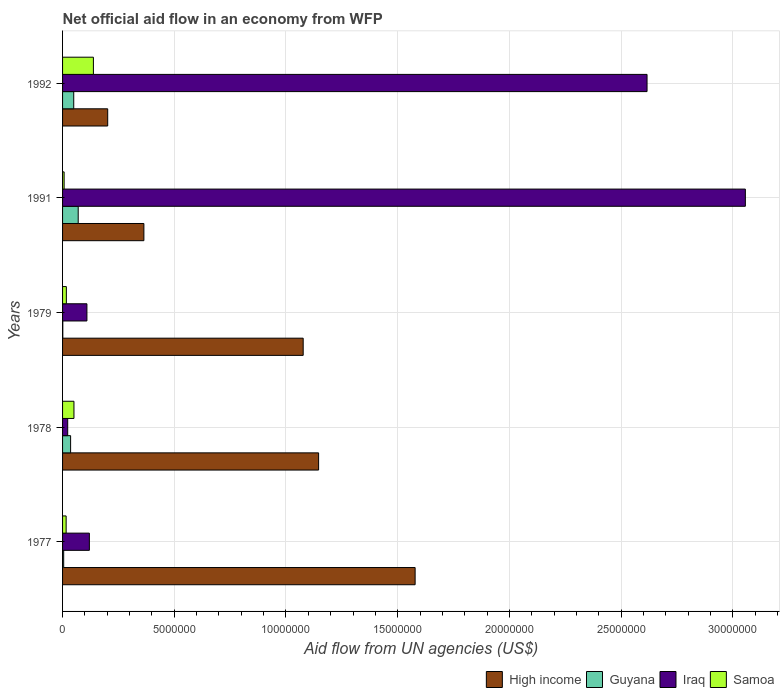How many different coloured bars are there?
Make the answer very short. 4. How many groups of bars are there?
Offer a very short reply. 5. Are the number of bars per tick equal to the number of legend labels?
Keep it short and to the point. Yes. How many bars are there on the 1st tick from the top?
Your answer should be very brief. 4. What is the label of the 3rd group of bars from the top?
Your response must be concise. 1979. What is the net official aid flow in Iraq in 1979?
Offer a terse response. 1.09e+06. Across all years, what is the maximum net official aid flow in Iraq?
Provide a short and direct response. 3.06e+07. In which year was the net official aid flow in High income minimum?
Your response must be concise. 1992. What is the total net official aid flow in Iraq in the graph?
Offer a terse response. 5.92e+07. What is the difference between the net official aid flow in Iraq in 1979 and that in 1992?
Provide a short and direct response. -2.51e+07. What is the difference between the net official aid flow in Guyana in 1979 and the net official aid flow in High income in 1978?
Keep it short and to the point. -1.14e+07. What is the average net official aid flow in Iraq per year?
Give a very brief answer. 1.18e+07. In the year 1977, what is the difference between the net official aid flow in Iraq and net official aid flow in Samoa?
Offer a terse response. 1.04e+06. What is the ratio of the net official aid flow in Iraq in 1978 to that in 1992?
Provide a succinct answer. 0.01. What is the difference between the highest and the second highest net official aid flow in High income?
Your answer should be very brief. 4.32e+06. What is the difference between the highest and the lowest net official aid flow in High income?
Offer a terse response. 1.38e+07. In how many years, is the net official aid flow in Iraq greater than the average net official aid flow in Iraq taken over all years?
Provide a succinct answer. 2. Is the sum of the net official aid flow in Iraq in 1979 and 1992 greater than the maximum net official aid flow in High income across all years?
Offer a very short reply. Yes. What does the 1st bar from the top in 1992 represents?
Ensure brevity in your answer.  Samoa. What does the 4th bar from the bottom in 1991 represents?
Make the answer very short. Samoa. Is it the case that in every year, the sum of the net official aid flow in Samoa and net official aid flow in High income is greater than the net official aid flow in Guyana?
Offer a terse response. Yes. How many bars are there?
Provide a short and direct response. 20. Are all the bars in the graph horizontal?
Ensure brevity in your answer.  Yes. How many years are there in the graph?
Offer a very short reply. 5. Are the values on the major ticks of X-axis written in scientific E-notation?
Give a very brief answer. No. Does the graph contain any zero values?
Provide a short and direct response. No. How many legend labels are there?
Offer a very short reply. 4. What is the title of the graph?
Make the answer very short. Net official aid flow in an economy from WFP. What is the label or title of the X-axis?
Your answer should be compact. Aid flow from UN agencies (US$). What is the Aid flow from UN agencies (US$) of High income in 1977?
Your response must be concise. 1.58e+07. What is the Aid flow from UN agencies (US$) in Guyana in 1977?
Give a very brief answer. 5.00e+04. What is the Aid flow from UN agencies (US$) in Iraq in 1977?
Keep it short and to the point. 1.20e+06. What is the Aid flow from UN agencies (US$) in Samoa in 1977?
Give a very brief answer. 1.60e+05. What is the Aid flow from UN agencies (US$) of High income in 1978?
Keep it short and to the point. 1.15e+07. What is the Aid flow from UN agencies (US$) of Guyana in 1978?
Offer a very short reply. 3.60e+05. What is the Aid flow from UN agencies (US$) of Iraq in 1978?
Your answer should be very brief. 2.30e+05. What is the Aid flow from UN agencies (US$) of Samoa in 1978?
Offer a very short reply. 5.10e+05. What is the Aid flow from UN agencies (US$) in High income in 1979?
Ensure brevity in your answer.  1.08e+07. What is the Aid flow from UN agencies (US$) of Guyana in 1979?
Provide a short and direct response. 10000. What is the Aid flow from UN agencies (US$) of Iraq in 1979?
Provide a succinct answer. 1.09e+06. What is the Aid flow from UN agencies (US$) of High income in 1991?
Offer a terse response. 3.64e+06. What is the Aid flow from UN agencies (US$) of Guyana in 1991?
Your answer should be compact. 7.00e+05. What is the Aid flow from UN agencies (US$) of Iraq in 1991?
Your answer should be very brief. 3.06e+07. What is the Aid flow from UN agencies (US$) of High income in 1992?
Give a very brief answer. 2.02e+06. What is the Aid flow from UN agencies (US$) in Iraq in 1992?
Your answer should be very brief. 2.62e+07. What is the Aid flow from UN agencies (US$) of Samoa in 1992?
Your response must be concise. 1.38e+06. Across all years, what is the maximum Aid flow from UN agencies (US$) in High income?
Give a very brief answer. 1.58e+07. Across all years, what is the maximum Aid flow from UN agencies (US$) of Guyana?
Your response must be concise. 7.00e+05. Across all years, what is the maximum Aid flow from UN agencies (US$) of Iraq?
Give a very brief answer. 3.06e+07. Across all years, what is the maximum Aid flow from UN agencies (US$) of Samoa?
Give a very brief answer. 1.38e+06. Across all years, what is the minimum Aid flow from UN agencies (US$) of High income?
Your answer should be very brief. 2.02e+06. Across all years, what is the minimum Aid flow from UN agencies (US$) in Guyana?
Offer a terse response. 10000. Across all years, what is the minimum Aid flow from UN agencies (US$) in Iraq?
Your answer should be very brief. 2.30e+05. Across all years, what is the minimum Aid flow from UN agencies (US$) of Samoa?
Make the answer very short. 7.00e+04. What is the total Aid flow from UN agencies (US$) of High income in the graph?
Your answer should be very brief. 4.37e+07. What is the total Aid flow from UN agencies (US$) in Guyana in the graph?
Offer a terse response. 1.62e+06. What is the total Aid flow from UN agencies (US$) in Iraq in the graph?
Provide a succinct answer. 5.92e+07. What is the total Aid flow from UN agencies (US$) of Samoa in the graph?
Your answer should be very brief. 2.29e+06. What is the difference between the Aid flow from UN agencies (US$) in High income in 1977 and that in 1978?
Provide a short and direct response. 4.32e+06. What is the difference between the Aid flow from UN agencies (US$) in Guyana in 1977 and that in 1978?
Give a very brief answer. -3.10e+05. What is the difference between the Aid flow from UN agencies (US$) in Iraq in 1977 and that in 1978?
Offer a terse response. 9.70e+05. What is the difference between the Aid flow from UN agencies (US$) in Samoa in 1977 and that in 1978?
Ensure brevity in your answer.  -3.50e+05. What is the difference between the Aid flow from UN agencies (US$) of High income in 1977 and that in 1979?
Make the answer very short. 5.01e+06. What is the difference between the Aid flow from UN agencies (US$) of Iraq in 1977 and that in 1979?
Keep it short and to the point. 1.10e+05. What is the difference between the Aid flow from UN agencies (US$) in Samoa in 1977 and that in 1979?
Give a very brief answer. -10000. What is the difference between the Aid flow from UN agencies (US$) of High income in 1977 and that in 1991?
Offer a very short reply. 1.21e+07. What is the difference between the Aid flow from UN agencies (US$) of Guyana in 1977 and that in 1991?
Keep it short and to the point. -6.50e+05. What is the difference between the Aid flow from UN agencies (US$) of Iraq in 1977 and that in 1991?
Make the answer very short. -2.94e+07. What is the difference between the Aid flow from UN agencies (US$) in High income in 1977 and that in 1992?
Ensure brevity in your answer.  1.38e+07. What is the difference between the Aid flow from UN agencies (US$) in Guyana in 1977 and that in 1992?
Offer a terse response. -4.50e+05. What is the difference between the Aid flow from UN agencies (US$) of Iraq in 1977 and that in 1992?
Your answer should be compact. -2.50e+07. What is the difference between the Aid flow from UN agencies (US$) in Samoa in 1977 and that in 1992?
Provide a succinct answer. -1.22e+06. What is the difference between the Aid flow from UN agencies (US$) in High income in 1978 and that in 1979?
Keep it short and to the point. 6.90e+05. What is the difference between the Aid flow from UN agencies (US$) of Iraq in 1978 and that in 1979?
Ensure brevity in your answer.  -8.60e+05. What is the difference between the Aid flow from UN agencies (US$) of Samoa in 1978 and that in 1979?
Provide a short and direct response. 3.40e+05. What is the difference between the Aid flow from UN agencies (US$) of High income in 1978 and that in 1991?
Keep it short and to the point. 7.82e+06. What is the difference between the Aid flow from UN agencies (US$) of Guyana in 1978 and that in 1991?
Give a very brief answer. -3.40e+05. What is the difference between the Aid flow from UN agencies (US$) of Iraq in 1978 and that in 1991?
Your answer should be very brief. -3.03e+07. What is the difference between the Aid flow from UN agencies (US$) in High income in 1978 and that in 1992?
Give a very brief answer. 9.44e+06. What is the difference between the Aid flow from UN agencies (US$) in Iraq in 1978 and that in 1992?
Give a very brief answer. -2.59e+07. What is the difference between the Aid flow from UN agencies (US$) in Samoa in 1978 and that in 1992?
Give a very brief answer. -8.70e+05. What is the difference between the Aid flow from UN agencies (US$) of High income in 1979 and that in 1991?
Provide a short and direct response. 7.13e+06. What is the difference between the Aid flow from UN agencies (US$) in Guyana in 1979 and that in 1991?
Offer a very short reply. -6.90e+05. What is the difference between the Aid flow from UN agencies (US$) of Iraq in 1979 and that in 1991?
Offer a terse response. -2.95e+07. What is the difference between the Aid flow from UN agencies (US$) of Samoa in 1979 and that in 1991?
Offer a terse response. 1.00e+05. What is the difference between the Aid flow from UN agencies (US$) in High income in 1979 and that in 1992?
Your answer should be very brief. 8.75e+06. What is the difference between the Aid flow from UN agencies (US$) in Guyana in 1979 and that in 1992?
Keep it short and to the point. -4.90e+05. What is the difference between the Aid flow from UN agencies (US$) in Iraq in 1979 and that in 1992?
Give a very brief answer. -2.51e+07. What is the difference between the Aid flow from UN agencies (US$) of Samoa in 1979 and that in 1992?
Your response must be concise. -1.21e+06. What is the difference between the Aid flow from UN agencies (US$) in High income in 1991 and that in 1992?
Your answer should be very brief. 1.62e+06. What is the difference between the Aid flow from UN agencies (US$) of Guyana in 1991 and that in 1992?
Make the answer very short. 2.00e+05. What is the difference between the Aid flow from UN agencies (US$) of Iraq in 1991 and that in 1992?
Provide a short and direct response. 4.40e+06. What is the difference between the Aid flow from UN agencies (US$) in Samoa in 1991 and that in 1992?
Keep it short and to the point. -1.31e+06. What is the difference between the Aid flow from UN agencies (US$) of High income in 1977 and the Aid flow from UN agencies (US$) of Guyana in 1978?
Your response must be concise. 1.54e+07. What is the difference between the Aid flow from UN agencies (US$) of High income in 1977 and the Aid flow from UN agencies (US$) of Iraq in 1978?
Make the answer very short. 1.56e+07. What is the difference between the Aid flow from UN agencies (US$) in High income in 1977 and the Aid flow from UN agencies (US$) in Samoa in 1978?
Give a very brief answer. 1.53e+07. What is the difference between the Aid flow from UN agencies (US$) of Guyana in 1977 and the Aid flow from UN agencies (US$) of Iraq in 1978?
Give a very brief answer. -1.80e+05. What is the difference between the Aid flow from UN agencies (US$) of Guyana in 1977 and the Aid flow from UN agencies (US$) of Samoa in 1978?
Provide a succinct answer. -4.60e+05. What is the difference between the Aid flow from UN agencies (US$) in Iraq in 1977 and the Aid flow from UN agencies (US$) in Samoa in 1978?
Give a very brief answer. 6.90e+05. What is the difference between the Aid flow from UN agencies (US$) in High income in 1977 and the Aid flow from UN agencies (US$) in Guyana in 1979?
Ensure brevity in your answer.  1.58e+07. What is the difference between the Aid flow from UN agencies (US$) in High income in 1977 and the Aid flow from UN agencies (US$) in Iraq in 1979?
Ensure brevity in your answer.  1.47e+07. What is the difference between the Aid flow from UN agencies (US$) of High income in 1977 and the Aid flow from UN agencies (US$) of Samoa in 1979?
Provide a succinct answer. 1.56e+07. What is the difference between the Aid flow from UN agencies (US$) of Guyana in 1977 and the Aid flow from UN agencies (US$) of Iraq in 1979?
Offer a terse response. -1.04e+06. What is the difference between the Aid flow from UN agencies (US$) of Iraq in 1977 and the Aid flow from UN agencies (US$) of Samoa in 1979?
Your answer should be very brief. 1.03e+06. What is the difference between the Aid flow from UN agencies (US$) in High income in 1977 and the Aid flow from UN agencies (US$) in Guyana in 1991?
Offer a very short reply. 1.51e+07. What is the difference between the Aid flow from UN agencies (US$) of High income in 1977 and the Aid flow from UN agencies (US$) of Iraq in 1991?
Make the answer very short. -1.48e+07. What is the difference between the Aid flow from UN agencies (US$) of High income in 1977 and the Aid flow from UN agencies (US$) of Samoa in 1991?
Give a very brief answer. 1.57e+07. What is the difference between the Aid flow from UN agencies (US$) in Guyana in 1977 and the Aid flow from UN agencies (US$) in Iraq in 1991?
Provide a succinct answer. -3.05e+07. What is the difference between the Aid flow from UN agencies (US$) in Guyana in 1977 and the Aid flow from UN agencies (US$) in Samoa in 1991?
Make the answer very short. -2.00e+04. What is the difference between the Aid flow from UN agencies (US$) of Iraq in 1977 and the Aid flow from UN agencies (US$) of Samoa in 1991?
Offer a terse response. 1.13e+06. What is the difference between the Aid flow from UN agencies (US$) of High income in 1977 and the Aid flow from UN agencies (US$) of Guyana in 1992?
Offer a terse response. 1.53e+07. What is the difference between the Aid flow from UN agencies (US$) of High income in 1977 and the Aid flow from UN agencies (US$) of Iraq in 1992?
Provide a short and direct response. -1.04e+07. What is the difference between the Aid flow from UN agencies (US$) in High income in 1977 and the Aid flow from UN agencies (US$) in Samoa in 1992?
Make the answer very short. 1.44e+07. What is the difference between the Aid flow from UN agencies (US$) of Guyana in 1977 and the Aid flow from UN agencies (US$) of Iraq in 1992?
Keep it short and to the point. -2.61e+07. What is the difference between the Aid flow from UN agencies (US$) in Guyana in 1977 and the Aid flow from UN agencies (US$) in Samoa in 1992?
Your response must be concise. -1.33e+06. What is the difference between the Aid flow from UN agencies (US$) of High income in 1978 and the Aid flow from UN agencies (US$) of Guyana in 1979?
Your answer should be very brief. 1.14e+07. What is the difference between the Aid flow from UN agencies (US$) of High income in 1978 and the Aid flow from UN agencies (US$) of Iraq in 1979?
Your answer should be very brief. 1.04e+07. What is the difference between the Aid flow from UN agencies (US$) of High income in 1978 and the Aid flow from UN agencies (US$) of Samoa in 1979?
Provide a short and direct response. 1.13e+07. What is the difference between the Aid flow from UN agencies (US$) of Guyana in 1978 and the Aid flow from UN agencies (US$) of Iraq in 1979?
Keep it short and to the point. -7.30e+05. What is the difference between the Aid flow from UN agencies (US$) in Guyana in 1978 and the Aid flow from UN agencies (US$) in Samoa in 1979?
Offer a very short reply. 1.90e+05. What is the difference between the Aid flow from UN agencies (US$) in High income in 1978 and the Aid flow from UN agencies (US$) in Guyana in 1991?
Ensure brevity in your answer.  1.08e+07. What is the difference between the Aid flow from UN agencies (US$) in High income in 1978 and the Aid flow from UN agencies (US$) in Iraq in 1991?
Provide a short and direct response. -1.91e+07. What is the difference between the Aid flow from UN agencies (US$) of High income in 1978 and the Aid flow from UN agencies (US$) of Samoa in 1991?
Offer a terse response. 1.14e+07. What is the difference between the Aid flow from UN agencies (US$) of Guyana in 1978 and the Aid flow from UN agencies (US$) of Iraq in 1991?
Ensure brevity in your answer.  -3.02e+07. What is the difference between the Aid flow from UN agencies (US$) of Guyana in 1978 and the Aid flow from UN agencies (US$) of Samoa in 1991?
Offer a terse response. 2.90e+05. What is the difference between the Aid flow from UN agencies (US$) in Iraq in 1978 and the Aid flow from UN agencies (US$) in Samoa in 1991?
Make the answer very short. 1.60e+05. What is the difference between the Aid flow from UN agencies (US$) in High income in 1978 and the Aid flow from UN agencies (US$) in Guyana in 1992?
Your answer should be compact. 1.10e+07. What is the difference between the Aid flow from UN agencies (US$) in High income in 1978 and the Aid flow from UN agencies (US$) in Iraq in 1992?
Offer a very short reply. -1.47e+07. What is the difference between the Aid flow from UN agencies (US$) of High income in 1978 and the Aid flow from UN agencies (US$) of Samoa in 1992?
Make the answer very short. 1.01e+07. What is the difference between the Aid flow from UN agencies (US$) in Guyana in 1978 and the Aid flow from UN agencies (US$) in Iraq in 1992?
Provide a short and direct response. -2.58e+07. What is the difference between the Aid flow from UN agencies (US$) of Guyana in 1978 and the Aid flow from UN agencies (US$) of Samoa in 1992?
Provide a succinct answer. -1.02e+06. What is the difference between the Aid flow from UN agencies (US$) in Iraq in 1978 and the Aid flow from UN agencies (US$) in Samoa in 1992?
Your answer should be very brief. -1.15e+06. What is the difference between the Aid flow from UN agencies (US$) of High income in 1979 and the Aid flow from UN agencies (US$) of Guyana in 1991?
Your response must be concise. 1.01e+07. What is the difference between the Aid flow from UN agencies (US$) in High income in 1979 and the Aid flow from UN agencies (US$) in Iraq in 1991?
Give a very brief answer. -1.98e+07. What is the difference between the Aid flow from UN agencies (US$) in High income in 1979 and the Aid flow from UN agencies (US$) in Samoa in 1991?
Offer a very short reply. 1.07e+07. What is the difference between the Aid flow from UN agencies (US$) of Guyana in 1979 and the Aid flow from UN agencies (US$) of Iraq in 1991?
Offer a very short reply. -3.06e+07. What is the difference between the Aid flow from UN agencies (US$) of Guyana in 1979 and the Aid flow from UN agencies (US$) of Samoa in 1991?
Your answer should be compact. -6.00e+04. What is the difference between the Aid flow from UN agencies (US$) in Iraq in 1979 and the Aid flow from UN agencies (US$) in Samoa in 1991?
Give a very brief answer. 1.02e+06. What is the difference between the Aid flow from UN agencies (US$) in High income in 1979 and the Aid flow from UN agencies (US$) in Guyana in 1992?
Ensure brevity in your answer.  1.03e+07. What is the difference between the Aid flow from UN agencies (US$) of High income in 1979 and the Aid flow from UN agencies (US$) of Iraq in 1992?
Your response must be concise. -1.54e+07. What is the difference between the Aid flow from UN agencies (US$) of High income in 1979 and the Aid flow from UN agencies (US$) of Samoa in 1992?
Your answer should be very brief. 9.39e+06. What is the difference between the Aid flow from UN agencies (US$) in Guyana in 1979 and the Aid flow from UN agencies (US$) in Iraq in 1992?
Make the answer very short. -2.62e+07. What is the difference between the Aid flow from UN agencies (US$) in Guyana in 1979 and the Aid flow from UN agencies (US$) in Samoa in 1992?
Offer a terse response. -1.37e+06. What is the difference between the Aid flow from UN agencies (US$) of High income in 1991 and the Aid flow from UN agencies (US$) of Guyana in 1992?
Make the answer very short. 3.14e+06. What is the difference between the Aid flow from UN agencies (US$) in High income in 1991 and the Aid flow from UN agencies (US$) in Iraq in 1992?
Keep it short and to the point. -2.25e+07. What is the difference between the Aid flow from UN agencies (US$) in High income in 1991 and the Aid flow from UN agencies (US$) in Samoa in 1992?
Your answer should be very brief. 2.26e+06. What is the difference between the Aid flow from UN agencies (US$) of Guyana in 1991 and the Aid flow from UN agencies (US$) of Iraq in 1992?
Make the answer very short. -2.55e+07. What is the difference between the Aid flow from UN agencies (US$) of Guyana in 1991 and the Aid flow from UN agencies (US$) of Samoa in 1992?
Your answer should be very brief. -6.80e+05. What is the difference between the Aid flow from UN agencies (US$) of Iraq in 1991 and the Aid flow from UN agencies (US$) of Samoa in 1992?
Keep it short and to the point. 2.92e+07. What is the average Aid flow from UN agencies (US$) of High income per year?
Provide a succinct answer. 8.73e+06. What is the average Aid flow from UN agencies (US$) of Guyana per year?
Your response must be concise. 3.24e+05. What is the average Aid flow from UN agencies (US$) in Iraq per year?
Offer a terse response. 1.18e+07. What is the average Aid flow from UN agencies (US$) in Samoa per year?
Make the answer very short. 4.58e+05. In the year 1977, what is the difference between the Aid flow from UN agencies (US$) of High income and Aid flow from UN agencies (US$) of Guyana?
Your answer should be compact. 1.57e+07. In the year 1977, what is the difference between the Aid flow from UN agencies (US$) of High income and Aid flow from UN agencies (US$) of Iraq?
Your response must be concise. 1.46e+07. In the year 1977, what is the difference between the Aid flow from UN agencies (US$) of High income and Aid flow from UN agencies (US$) of Samoa?
Provide a succinct answer. 1.56e+07. In the year 1977, what is the difference between the Aid flow from UN agencies (US$) in Guyana and Aid flow from UN agencies (US$) in Iraq?
Provide a short and direct response. -1.15e+06. In the year 1977, what is the difference between the Aid flow from UN agencies (US$) in Iraq and Aid flow from UN agencies (US$) in Samoa?
Ensure brevity in your answer.  1.04e+06. In the year 1978, what is the difference between the Aid flow from UN agencies (US$) of High income and Aid flow from UN agencies (US$) of Guyana?
Keep it short and to the point. 1.11e+07. In the year 1978, what is the difference between the Aid flow from UN agencies (US$) in High income and Aid flow from UN agencies (US$) in Iraq?
Your answer should be very brief. 1.12e+07. In the year 1978, what is the difference between the Aid flow from UN agencies (US$) of High income and Aid flow from UN agencies (US$) of Samoa?
Keep it short and to the point. 1.10e+07. In the year 1978, what is the difference between the Aid flow from UN agencies (US$) in Guyana and Aid flow from UN agencies (US$) in Iraq?
Keep it short and to the point. 1.30e+05. In the year 1978, what is the difference between the Aid flow from UN agencies (US$) in Iraq and Aid flow from UN agencies (US$) in Samoa?
Give a very brief answer. -2.80e+05. In the year 1979, what is the difference between the Aid flow from UN agencies (US$) in High income and Aid flow from UN agencies (US$) in Guyana?
Make the answer very short. 1.08e+07. In the year 1979, what is the difference between the Aid flow from UN agencies (US$) in High income and Aid flow from UN agencies (US$) in Iraq?
Make the answer very short. 9.68e+06. In the year 1979, what is the difference between the Aid flow from UN agencies (US$) in High income and Aid flow from UN agencies (US$) in Samoa?
Keep it short and to the point. 1.06e+07. In the year 1979, what is the difference between the Aid flow from UN agencies (US$) of Guyana and Aid flow from UN agencies (US$) of Iraq?
Keep it short and to the point. -1.08e+06. In the year 1979, what is the difference between the Aid flow from UN agencies (US$) in Guyana and Aid flow from UN agencies (US$) in Samoa?
Your answer should be compact. -1.60e+05. In the year 1979, what is the difference between the Aid flow from UN agencies (US$) in Iraq and Aid flow from UN agencies (US$) in Samoa?
Make the answer very short. 9.20e+05. In the year 1991, what is the difference between the Aid flow from UN agencies (US$) in High income and Aid flow from UN agencies (US$) in Guyana?
Your answer should be very brief. 2.94e+06. In the year 1991, what is the difference between the Aid flow from UN agencies (US$) of High income and Aid flow from UN agencies (US$) of Iraq?
Your answer should be compact. -2.69e+07. In the year 1991, what is the difference between the Aid flow from UN agencies (US$) of High income and Aid flow from UN agencies (US$) of Samoa?
Your answer should be compact. 3.57e+06. In the year 1991, what is the difference between the Aid flow from UN agencies (US$) of Guyana and Aid flow from UN agencies (US$) of Iraq?
Give a very brief answer. -2.99e+07. In the year 1991, what is the difference between the Aid flow from UN agencies (US$) in Guyana and Aid flow from UN agencies (US$) in Samoa?
Make the answer very short. 6.30e+05. In the year 1991, what is the difference between the Aid flow from UN agencies (US$) in Iraq and Aid flow from UN agencies (US$) in Samoa?
Offer a terse response. 3.05e+07. In the year 1992, what is the difference between the Aid flow from UN agencies (US$) in High income and Aid flow from UN agencies (US$) in Guyana?
Your answer should be very brief. 1.52e+06. In the year 1992, what is the difference between the Aid flow from UN agencies (US$) in High income and Aid flow from UN agencies (US$) in Iraq?
Offer a very short reply. -2.41e+07. In the year 1992, what is the difference between the Aid flow from UN agencies (US$) of High income and Aid flow from UN agencies (US$) of Samoa?
Offer a very short reply. 6.40e+05. In the year 1992, what is the difference between the Aid flow from UN agencies (US$) in Guyana and Aid flow from UN agencies (US$) in Iraq?
Offer a very short reply. -2.57e+07. In the year 1992, what is the difference between the Aid flow from UN agencies (US$) of Guyana and Aid flow from UN agencies (US$) of Samoa?
Ensure brevity in your answer.  -8.80e+05. In the year 1992, what is the difference between the Aid flow from UN agencies (US$) of Iraq and Aid flow from UN agencies (US$) of Samoa?
Make the answer very short. 2.48e+07. What is the ratio of the Aid flow from UN agencies (US$) in High income in 1977 to that in 1978?
Make the answer very short. 1.38. What is the ratio of the Aid flow from UN agencies (US$) in Guyana in 1977 to that in 1978?
Provide a succinct answer. 0.14. What is the ratio of the Aid flow from UN agencies (US$) of Iraq in 1977 to that in 1978?
Your answer should be compact. 5.22. What is the ratio of the Aid flow from UN agencies (US$) of Samoa in 1977 to that in 1978?
Your answer should be compact. 0.31. What is the ratio of the Aid flow from UN agencies (US$) in High income in 1977 to that in 1979?
Your answer should be very brief. 1.47. What is the ratio of the Aid flow from UN agencies (US$) in Iraq in 1977 to that in 1979?
Offer a very short reply. 1.1. What is the ratio of the Aid flow from UN agencies (US$) in Samoa in 1977 to that in 1979?
Give a very brief answer. 0.94. What is the ratio of the Aid flow from UN agencies (US$) in High income in 1977 to that in 1991?
Your response must be concise. 4.34. What is the ratio of the Aid flow from UN agencies (US$) in Guyana in 1977 to that in 1991?
Ensure brevity in your answer.  0.07. What is the ratio of the Aid flow from UN agencies (US$) in Iraq in 1977 to that in 1991?
Make the answer very short. 0.04. What is the ratio of the Aid flow from UN agencies (US$) in Samoa in 1977 to that in 1991?
Your response must be concise. 2.29. What is the ratio of the Aid flow from UN agencies (US$) of High income in 1977 to that in 1992?
Your response must be concise. 7.81. What is the ratio of the Aid flow from UN agencies (US$) in Iraq in 1977 to that in 1992?
Offer a terse response. 0.05. What is the ratio of the Aid flow from UN agencies (US$) of Samoa in 1977 to that in 1992?
Offer a terse response. 0.12. What is the ratio of the Aid flow from UN agencies (US$) in High income in 1978 to that in 1979?
Keep it short and to the point. 1.06. What is the ratio of the Aid flow from UN agencies (US$) of Iraq in 1978 to that in 1979?
Give a very brief answer. 0.21. What is the ratio of the Aid flow from UN agencies (US$) of Samoa in 1978 to that in 1979?
Ensure brevity in your answer.  3. What is the ratio of the Aid flow from UN agencies (US$) in High income in 1978 to that in 1991?
Provide a succinct answer. 3.15. What is the ratio of the Aid flow from UN agencies (US$) of Guyana in 1978 to that in 1991?
Keep it short and to the point. 0.51. What is the ratio of the Aid flow from UN agencies (US$) of Iraq in 1978 to that in 1991?
Give a very brief answer. 0.01. What is the ratio of the Aid flow from UN agencies (US$) in Samoa in 1978 to that in 1991?
Ensure brevity in your answer.  7.29. What is the ratio of the Aid flow from UN agencies (US$) in High income in 1978 to that in 1992?
Ensure brevity in your answer.  5.67. What is the ratio of the Aid flow from UN agencies (US$) in Guyana in 1978 to that in 1992?
Provide a succinct answer. 0.72. What is the ratio of the Aid flow from UN agencies (US$) in Iraq in 1978 to that in 1992?
Make the answer very short. 0.01. What is the ratio of the Aid flow from UN agencies (US$) in Samoa in 1978 to that in 1992?
Your answer should be compact. 0.37. What is the ratio of the Aid flow from UN agencies (US$) in High income in 1979 to that in 1991?
Offer a terse response. 2.96. What is the ratio of the Aid flow from UN agencies (US$) of Guyana in 1979 to that in 1991?
Offer a very short reply. 0.01. What is the ratio of the Aid flow from UN agencies (US$) of Iraq in 1979 to that in 1991?
Make the answer very short. 0.04. What is the ratio of the Aid flow from UN agencies (US$) of Samoa in 1979 to that in 1991?
Your answer should be compact. 2.43. What is the ratio of the Aid flow from UN agencies (US$) of High income in 1979 to that in 1992?
Ensure brevity in your answer.  5.33. What is the ratio of the Aid flow from UN agencies (US$) in Iraq in 1979 to that in 1992?
Offer a terse response. 0.04. What is the ratio of the Aid flow from UN agencies (US$) of Samoa in 1979 to that in 1992?
Ensure brevity in your answer.  0.12. What is the ratio of the Aid flow from UN agencies (US$) of High income in 1991 to that in 1992?
Ensure brevity in your answer.  1.8. What is the ratio of the Aid flow from UN agencies (US$) in Iraq in 1991 to that in 1992?
Ensure brevity in your answer.  1.17. What is the ratio of the Aid flow from UN agencies (US$) of Samoa in 1991 to that in 1992?
Give a very brief answer. 0.05. What is the difference between the highest and the second highest Aid flow from UN agencies (US$) of High income?
Keep it short and to the point. 4.32e+06. What is the difference between the highest and the second highest Aid flow from UN agencies (US$) of Guyana?
Your answer should be compact. 2.00e+05. What is the difference between the highest and the second highest Aid flow from UN agencies (US$) in Iraq?
Your answer should be very brief. 4.40e+06. What is the difference between the highest and the second highest Aid flow from UN agencies (US$) in Samoa?
Make the answer very short. 8.70e+05. What is the difference between the highest and the lowest Aid flow from UN agencies (US$) of High income?
Give a very brief answer. 1.38e+07. What is the difference between the highest and the lowest Aid flow from UN agencies (US$) in Guyana?
Your answer should be very brief. 6.90e+05. What is the difference between the highest and the lowest Aid flow from UN agencies (US$) of Iraq?
Offer a terse response. 3.03e+07. What is the difference between the highest and the lowest Aid flow from UN agencies (US$) in Samoa?
Your answer should be compact. 1.31e+06. 